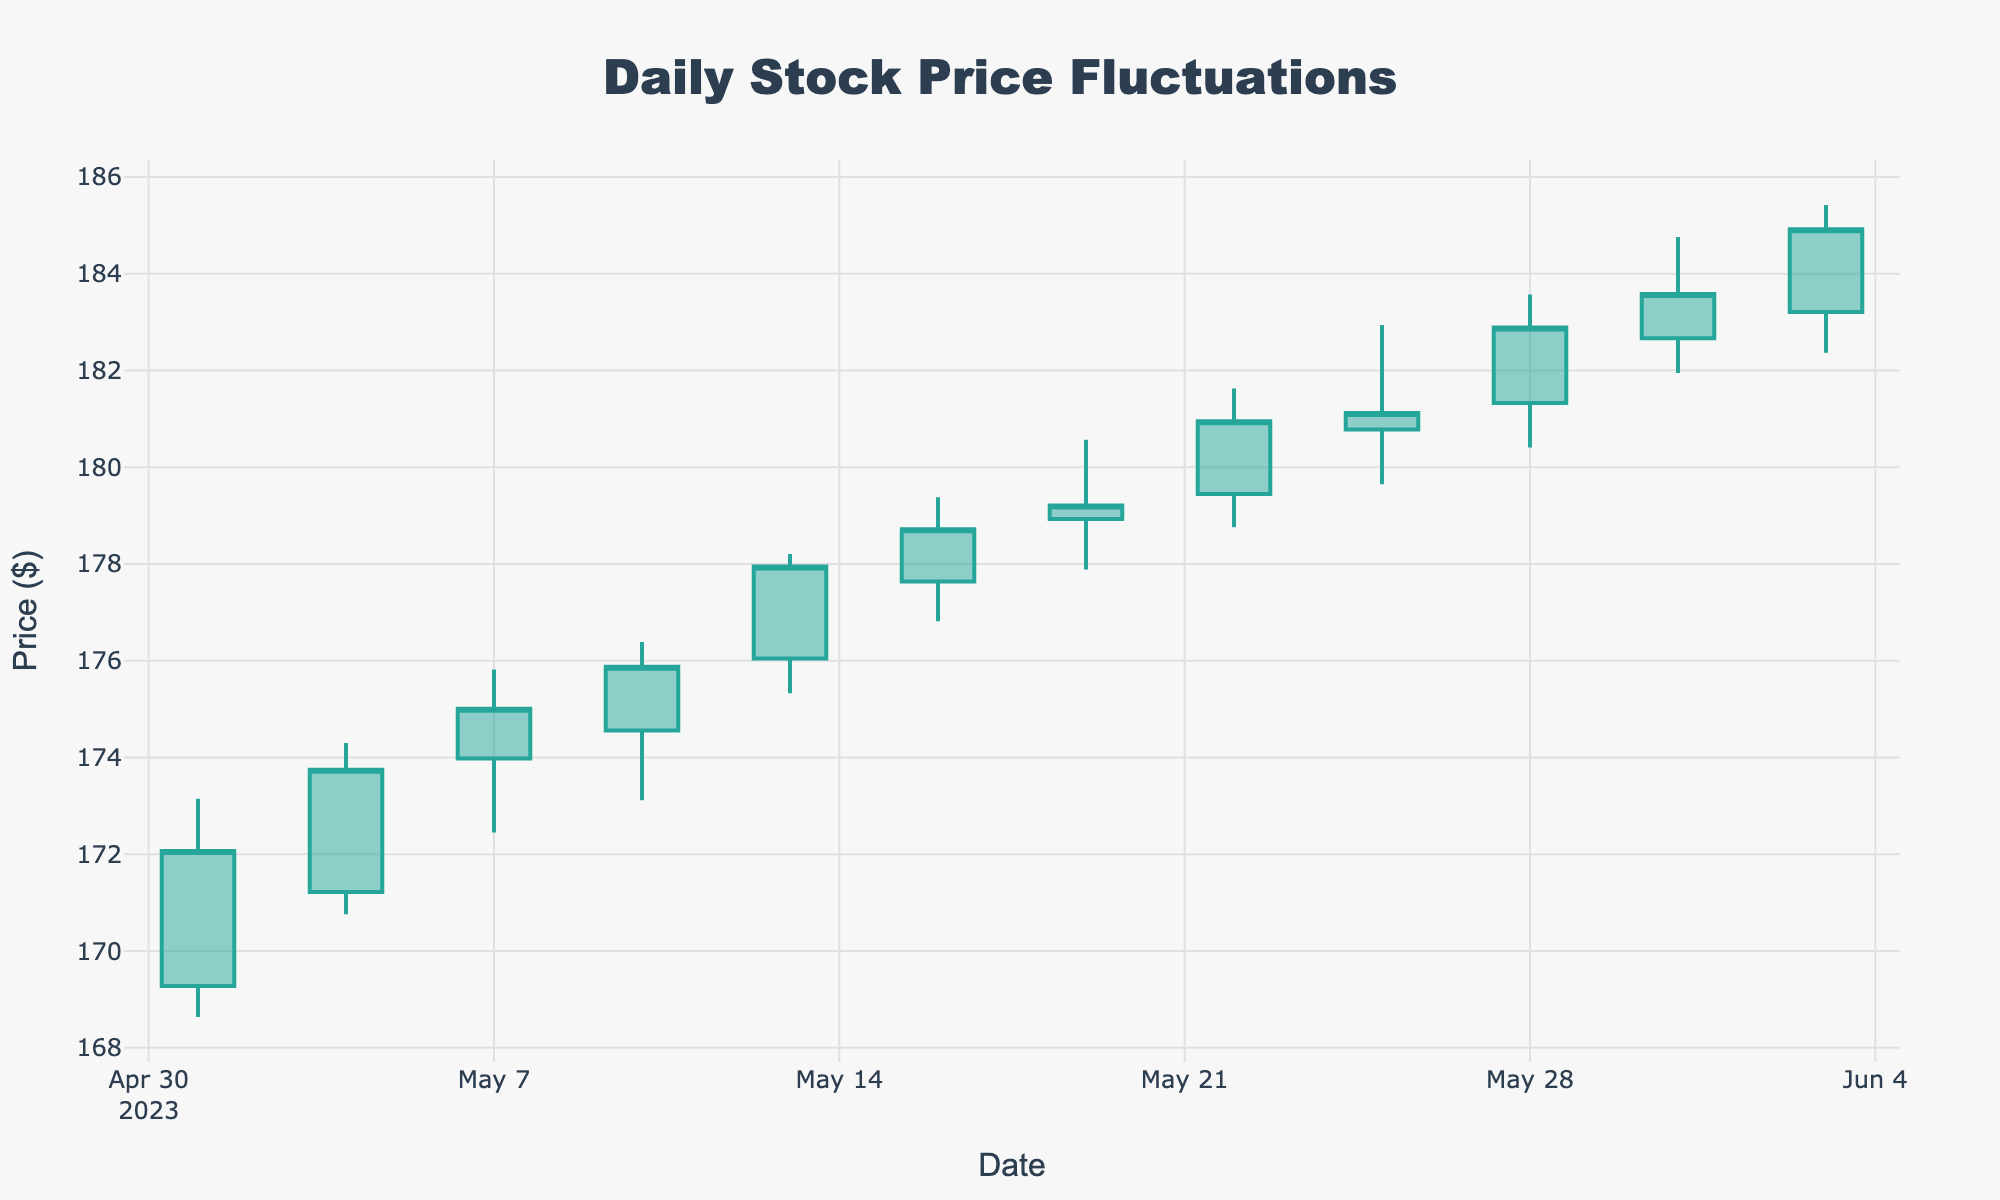What is the title of the chart? The title of the chart is displayed at the top and is centered within the chart layout. It is labeled within the `title` attribute of the layout.
Answer: Daily Stock Price Fluctuations What are the colors used to represent increasing and decreasing prices? The colors used to represent increasing prices are generally shades of green, while decreasing prices are in shades of red. This is often reflected in the plot layout.
Answer: Green and Red How many data points are displayed on the chart? By counting the candlesticks on the chart, which represent the dates listed, you can determine the number of data points.
Answer: 12 On which date did the highest high occur, and what was the value? To find the highest high, look at the upper shadows (wicks) of the candlesticks and identify the tallest one. Cross-reference the date associated with this high value.
Answer: 2023-06-03, 185.42 What is the average closing price over the month? To calculate the average, add up all the closing prices and then divide by the number of data points. The process involves summation and division.
Answer: (172.07 + 173.75 + 175.01 + 175.88 + 177.95 + 178.72 + 179.21 + 180.95 + 181.12 + 182.89 + 183.58 + 184.92)/12 = 178.68 How does the closing price on 2023-05-31 compare with 2023-05-01? Compare the closing prices on both dates by looking at the candlestick representing May 31 and May 01.
Answer: 2023-05-31 is higher than 2023-05-01 What is the range of prices (difference between high and low) on 2023-05-19? Identify the high and low prices for the specific date and subtract the low price from the high price.
Answer: 180.57 - 177.89 = 2.68 Did the stock experience a higher closing price on 2023-05-10 or 2023-05-13? Look at the closing prices for both dates and compare them. The one with the higher value is the answer.
Answer: 2023-05-13 What was the largest single-day closing price increase within the month? Calculate the difference in closing prices from one day to the next. Identify the largest positive difference.
Answer: 184.92 - 183.58 = 1.34 on 2023-06-03 On how many days did the closing price increase compared to the previous day? Review the closing prices day-by-day and count the instances where a day’s closing price is higher than the previous day’s closing price.
Answer: 6 